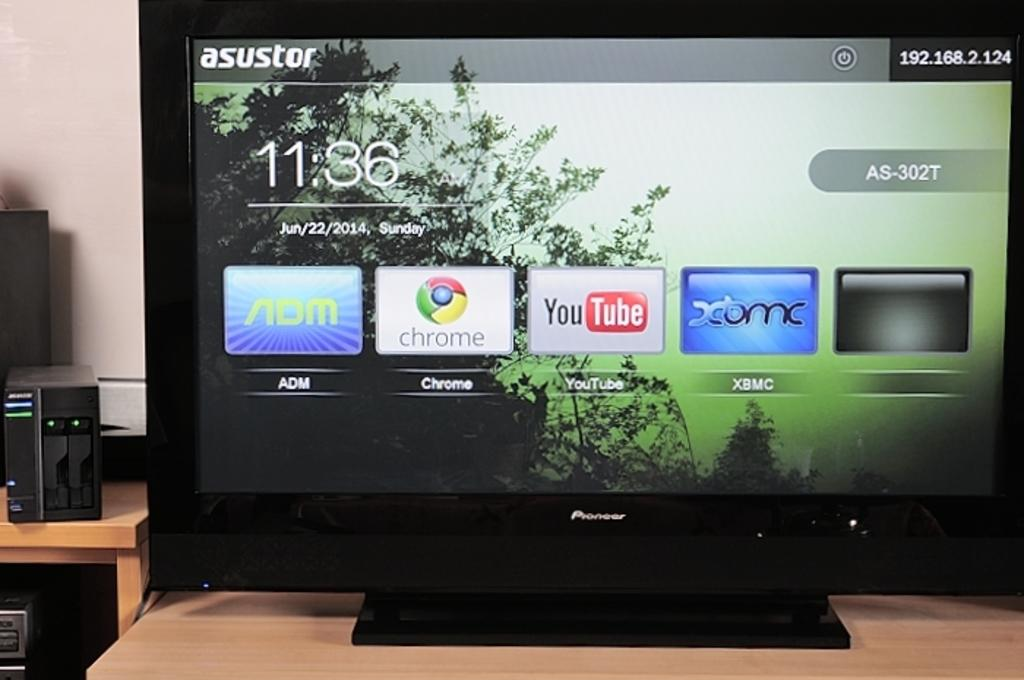<image>
Write a terse but informative summary of the picture. A smart TV screen shows icons for YouTube, Google Chrome, ADM and XMBC. 